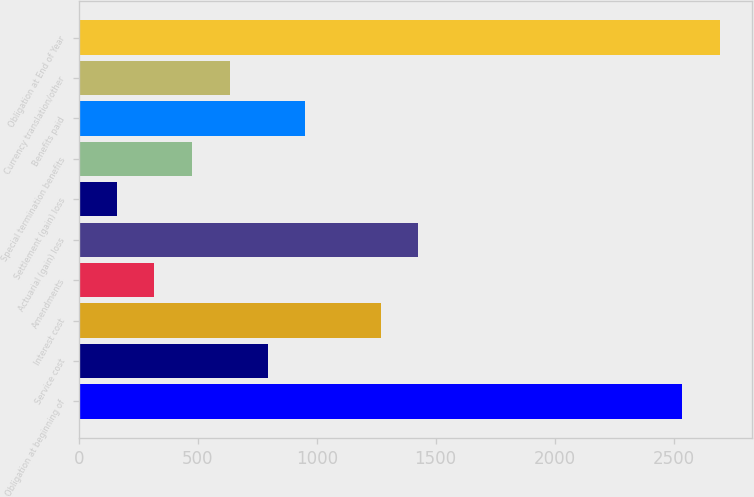Convert chart. <chart><loc_0><loc_0><loc_500><loc_500><bar_chart><fcel>Obligation at beginning of<fcel>Service cost<fcel>Interest cost<fcel>Amendments<fcel>Actuarial (gain) loss<fcel>Settlement (gain) loss<fcel>Special termination benefits<fcel>Benefits paid<fcel>Currency translation/other<fcel>Obligation at End of Year<nl><fcel>2535.34<fcel>793.05<fcel>1268.22<fcel>317.88<fcel>1426.61<fcel>159.49<fcel>476.27<fcel>951.44<fcel>634.66<fcel>2693.73<nl></chart> 